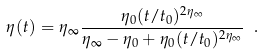Convert formula to latex. <formula><loc_0><loc_0><loc_500><loc_500>\eta ( t ) = \eta _ { \infty } \frac { \eta _ { 0 } ( t / t _ { 0 } ) ^ { 2 \eta _ { \infty } } } { \eta _ { \infty } - \eta _ { 0 } + \eta _ { 0 } ( t / t _ { 0 } ) ^ { 2 \eta _ { \infty } } } \ .</formula> 